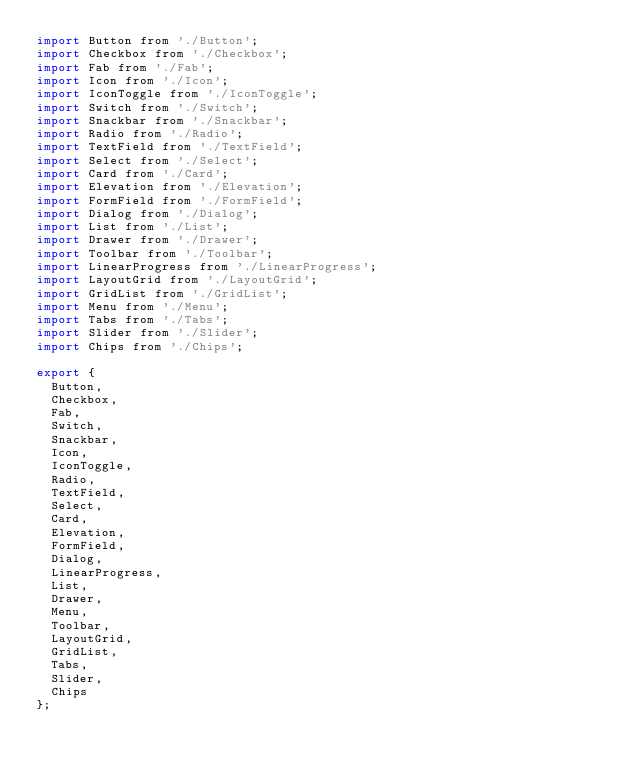Convert code to text. <code><loc_0><loc_0><loc_500><loc_500><_JavaScript_>import Button from './Button';
import Checkbox from './Checkbox';
import Fab from './Fab';
import Icon from './Icon';
import IconToggle from './IconToggle';
import Switch from './Switch';
import Snackbar from './Snackbar';
import Radio from './Radio';
import TextField from './TextField';
import Select from './Select';
import Card from './Card';
import Elevation from './Elevation';
import FormField from './FormField';
import Dialog from './Dialog';
import List from './List';
import Drawer from './Drawer';
import Toolbar from './Toolbar';
import LinearProgress from './LinearProgress';
import LayoutGrid from './LayoutGrid';
import GridList from './GridList';
import Menu from './Menu';
import Tabs from './Tabs';
import Slider from './Slider';
import Chips from './Chips';

export {
  Button,
  Checkbox,
  Fab,
  Switch,
  Snackbar,
  Icon,
  IconToggle,
  Radio,
  TextField,
  Select,
  Card,
  Elevation,
  FormField,
  Dialog,
  LinearProgress,
  List,
  Drawer,
  Menu,
  Toolbar,
  LayoutGrid,
  GridList,
  Tabs,
  Slider,
  Chips
};
</code> 